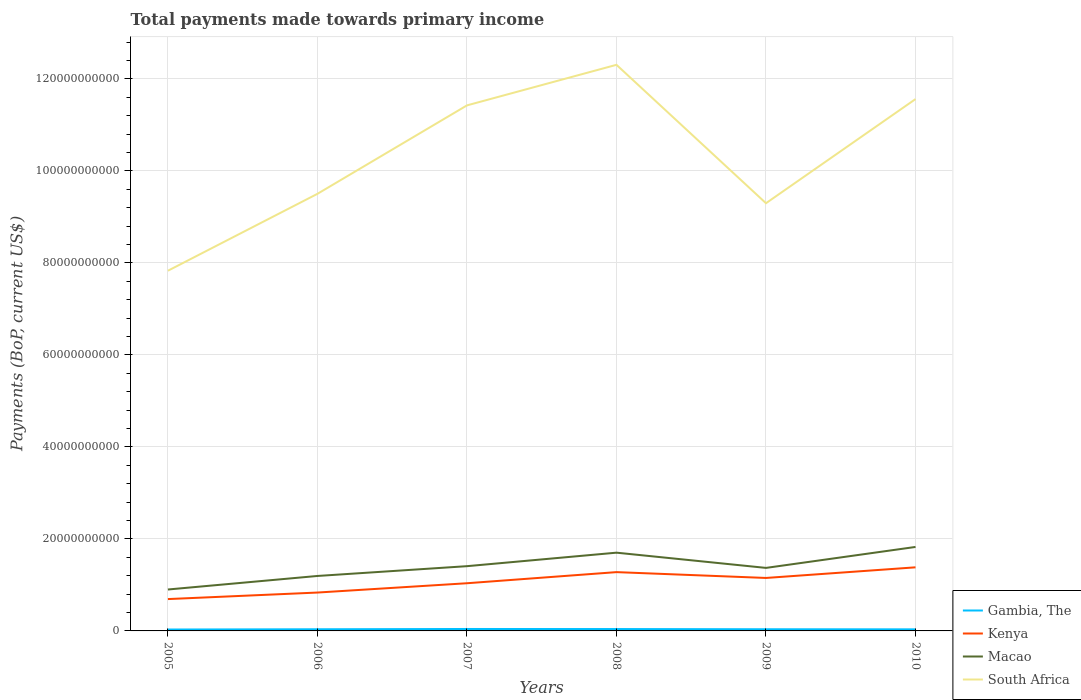How many different coloured lines are there?
Keep it short and to the point. 4. Across all years, what is the maximum total payments made towards primary income in Gambia, The?
Your answer should be compact. 3.05e+08. What is the total total payments made towards primary income in South Africa in the graph?
Make the answer very short. 3.01e+1. What is the difference between the highest and the second highest total payments made towards primary income in Kenya?
Offer a very short reply. 6.90e+09. Is the total payments made towards primary income in Gambia, The strictly greater than the total payments made towards primary income in Kenya over the years?
Make the answer very short. Yes. Are the values on the major ticks of Y-axis written in scientific E-notation?
Ensure brevity in your answer.  No. Does the graph contain grids?
Give a very brief answer. Yes. Where does the legend appear in the graph?
Offer a very short reply. Bottom right. How are the legend labels stacked?
Your answer should be compact. Vertical. What is the title of the graph?
Your answer should be very brief. Total payments made towards primary income. What is the label or title of the Y-axis?
Provide a short and direct response. Payments (BoP, current US$). What is the Payments (BoP, current US$) in Gambia, The in 2005?
Offer a very short reply. 3.05e+08. What is the Payments (BoP, current US$) of Kenya in 2005?
Offer a very short reply. 6.92e+09. What is the Payments (BoP, current US$) of Macao in 2005?
Your answer should be compact. 9.00e+09. What is the Payments (BoP, current US$) in South Africa in 2005?
Your response must be concise. 7.83e+1. What is the Payments (BoP, current US$) of Gambia, The in 2006?
Ensure brevity in your answer.  3.59e+08. What is the Payments (BoP, current US$) in Kenya in 2006?
Your answer should be very brief. 8.34e+09. What is the Payments (BoP, current US$) in Macao in 2006?
Make the answer very short. 1.19e+1. What is the Payments (BoP, current US$) in South Africa in 2006?
Your answer should be compact. 9.50e+1. What is the Payments (BoP, current US$) in Gambia, The in 2007?
Give a very brief answer. 4.20e+08. What is the Payments (BoP, current US$) of Kenya in 2007?
Your response must be concise. 1.04e+1. What is the Payments (BoP, current US$) of Macao in 2007?
Ensure brevity in your answer.  1.41e+1. What is the Payments (BoP, current US$) of South Africa in 2007?
Ensure brevity in your answer.  1.14e+11. What is the Payments (BoP, current US$) in Gambia, The in 2008?
Offer a very short reply. 4.07e+08. What is the Payments (BoP, current US$) in Kenya in 2008?
Make the answer very short. 1.28e+1. What is the Payments (BoP, current US$) in Macao in 2008?
Your answer should be very brief. 1.70e+1. What is the Payments (BoP, current US$) of South Africa in 2008?
Make the answer very short. 1.23e+11. What is the Payments (BoP, current US$) of Gambia, The in 2009?
Make the answer very short. 3.62e+08. What is the Payments (BoP, current US$) in Kenya in 2009?
Your answer should be very brief. 1.15e+1. What is the Payments (BoP, current US$) of Macao in 2009?
Provide a succinct answer. 1.37e+1. What is the Payments (BoP, current US$) in South Africa in 2009?
Keep it short and to the point. 9.30e+1. What is the Payments (BoP, current US$) of Gambia, The in 2010?
Your answer should be compact. 3.41e+08. What is the Payments (BoP, current US$) of Kenya in 2010?
Make the answer very short. 1.38e+1. What is the Payments (BoP, current US$) in Macao in 2010?
Offer a terse response. 1.83e+1. What is the Payments (BoP, current US$) in South Africa in 2010?
Ensure brevity in your answer.  1.16e+11. Across all years, what is the maximum Payments (BoP, current US$) in Gambia, The?
Give a very brief answer. 4.20e+08. Across all years, what is the maximum Payments (BoP, current US$) of Kenya?
Your answer should be very brief. 1.38e+1. Across all years, what is the maximum Payments (BoP, current US$) in Macao?
Provide a short and direct response. 1.83e+1. Across all years, what is the maximum Payments (BoP, current US$) in South Africa?
Your answer should be very brief. 1.23e+11. Across all years, what is the minimum Payments (BoP, current US$) in Gambia, The?
Ensure brevity in your answer.  3.05e+08. Across all years, what is the minimum Payments (BoP, current US$) in Kenya?
Provide a short and direct response. 6.92e+09. Across all years, what is the minimum Payments (BoP, current US$) in Macao?
Offer a very short reply. 9.00e+09. Across all years, what is the minimum Payments (BoP, current US$) of South Africa?
Provide a short and direct response. 7.83e+1. What is the total Payments (BoP, current US$) of Gambia, The in the graph?
Provide a short and direct response. 2.19e+09. What is the total Payments (BoP, current US$) in Kenya in the graph?
Give a very brief answer. 6.37e+1. What is the total Payments (BoP, current US$) in Macao in the graph?
Your answer should be very brief. 8.40e+1. What is the total Payments (BoP, current US$) of South Africa in the graph?
Make the answer very short. 6.19e+11. What is the difference between the Payments (BoP, current US$) in Gambia, The in 2005 and that in 2006?
Your answer should be compact. -5.36e+07. What is the difference between the Payments (BoP, current US$) in Kenya in 2005 and that in 2006?
Your response must be concise. -1.42e+09. What is the difference between the Payments (BoP, current US$) in Macao in 2005 and that in 2006?
Give a very brief answer. -2.94e+09. What is the difference between the Payments (BoP, current US$) of South Africa in 2005 and that in 2006?
Offer a terse response. -1.67e+1. What is the difference between the Payments (BoP, current US$) of Gambia, The in 2005 and that in 2007?
Give a very brief answer. -1.15e+08. What is the difference between the Payments (BoP, current US$) of Kenya in 2005 and that in 2007?
Ensure brevity in your answer.  -3.44e+09. What is the difference between the Payments (BoP, current US$) in Macao in 2005 and that in 2007?
Make the answer very short. -5.07e+09. What is the difference between the Payments (BoP, current US$) of South Africa in 2005 and that in 2007?
Give a very brief answer. -3.59e+1. What is the difference between the Payments (BoP, current US$) of Gambia, The in 2005 and that in 2008?
Give a very brief answer. -1.02e+08. What is the difference between the Payments (BoP, current US$) of Kenya in 2005 and that in 2008?
Offer a terse response. -5.86e+09. What is the difference between the Payments (BoP, current US$) of Macao in 2005 and that in 2008?
Your answer should be very brief. -8.00e+09. What is the difference between the Payments (BoP, current US$) of South Africa in 2005 and that in 2008?
Your answer should be very brief. -4.48e+1. What is the difference between the Payments (BoP, current US$) of Gambia, The in 2005 and that in 2009?
Make the answer very short. -5.73e+07. What is the difference between the Payments (BoP, current US$) of Kenya in 2005 and that in 2009?
Keep it short and to the point. -4.59e+09. What is the difference between the Payments (BoP, current US$) in Macao in 2005 and that in 2009?
Your answer should be very brief. -4.69e+09. What is the difference between the Payments (BoP, current US$) of South Africa in 2005 and that in 2009?
Make the answer very short. -1.47e+1. What is the difference between the Payments (BoP, current US$) in Gambia, The in 2005 and that in 2010?
Give a very brief answer. -3.63e+07. What is the difference between the Payments (BoP, current US$) of Kenya in 2005 and that in 2010?
Keep it short and to the point. -6.90e+09. What is the difference between the Payments (BoP, current US$) in Macao in 2005 and that in 2010?
Your response must be concise. -9.25e+09. What is the difference between the Payments (BoP, current US$) in South Africa in 2005 and that in 2010?
Your answer should be compact. -3.73e+1. What is the difference between the Payments (BoP, current US$) of Gambia, The in 2006 and that in 2007?
Ensure brevity in your answer.  -6.12e+07. What is the difference between the Payments (BoP, current US$) in Kenya in 2006 and that in 2007?
Give a very brief answer. -2.02e+09. What is the difference between the Payments (BoP, current US$) of Macao in 2006 and that in 2007?
Offer a very short reply. -2.13e+09. What is the difference between the Payments (BoP, current US$) of South Africa in 2006 and that in 2007?
Ensure brevity in your answer.  -1.92e+1. What is the difference between the Payments (BoP, current US$) of Gambia, The in 2006 and that in 2008?
Your answer should be very brief. -4.87e+07. What is the difference between the Payments (BoP, current US$) of Kenya in 2006 and that in 2008?
Offer a terse response. -4.44e+09. What is the difference between the Payments (BoP, current US$) of Macao in 2006 and that in 2008?
Offer a terse response. -5.06e+09. What is the difference between the Payments (BoP, current US$) of South Africa in 2006 and that in 2008?
Give a very brief answer. -2.80e+1. What is the difference between the Payments (BoP, current US$) of Gambia, The in 2006 and that in 2009?
Provide a succinct answer. -3.62e+06. What is the difference between the Payments (BoP, current US$) of Kenya in 2006 and that in 2009?
Offer a very short reply. -3.17e+09. What is the difference between the Payments (BoP, current US$) of Macao in 2006 and that in 2009?
Keep it short and to the point. -1.75e+09. What is the difference between the Payments (BoP, current US$) in South Africa in 2006 and that in 2009?
Give a very brief answer. 2.04e+09. What is the difference between the Payments (BoP, current US$) in Gambia, The in 2006 and that in 2010?
Your answer should be very brief. 1.73e+07. What is the difference between the Payments (BoP, current US$) of Kenya in 2006 and that in 2010?
Provide a short and direct response. -5.48e+09. What is the difference between the Payments (BoP, current US$) of Macao in 2006 and that in 2010?
Offer a terse response. -6.31e+09. What is the difference between the Payments (BoP, current US$) in South Africa in 2006 and that in 2010?
Offer a terse response. -2.06e+1. What is the difference between the Payments (BoP, current US$) in Gambia, The in 2007 and that in 2008?
Offer a very short reply. 1.25e+07. What is the difference between the Payments (BoP, current US$) of Kenya in 2007 and that in 2008?
Offer a terse response. -2.42e+09. What is the difference between the Payments (BoP, current US$) in Macao in 2007 and that in 2008?
Offer a very short reply. -2.93e+09. What is the difference between the Payments (BoP, current US$) in South Africa in 2007 and that in 2008?
Your answer should be very brief. -8.82e+09. What is the difference between the Payments (BoP, current US$) of Gambia, The in 2007 and that in 2009?
Make the answer very short. 5.75e+07. What is the difference between the Payments (BoP, current US$) of Kenya in 2007 and that in 2009?
Offer a very short reply. -1.15e+09. What is the difference between the Payments (BoP, current US$) of Macao in 2007 and that in 2009?
Offer a terse response. 3.76e+08. What is the difference between the Payments (BoP, current US$) of South Africa in 2007 and that in 2009?
Offer a very short reply. 2.13e+1. What is the difference between the Payments (BoP, current US$) in Gambia, The in 2007 and that in 2010?
Ensure brevity in your answer.  7.85e+07. What is the difference between the Payments (BoP, current US$) in Kenya in 2007 and that in 2010?
Keep it short and to the point. -3.46e+09. What is the difference between the Payments (BoP, current US$) of Macao in 2007 and that in 2010?
Ensure brevity in your answer.  -4.18e+09. What is the difference between the Payments (BoP, current US$) in South Africa in 2007 and that in 2010?
Provide a short and direct response. -1.37e+09. What is the difference between the Payments (BoP, current US$) of Gambia, The in 2008 and that in 2009?
Offer a terse response. 4.51e+07. What is the difference between the Payments (BoP, current US$) of Kenya in 2008 and that in 2009?
Your answer should be compact. 1.27e+09. What is the difference between the Payments (BoP, current US$) in Macao in 2008 and that in 2009?
Give a very brief answer. 3.31e+09. What is the difference between the Payments (BoP, current US$) in South Africa in 2008 and that in 2009?
Your answer should be very brief. 3.01e+1. What is the difference between the Payments (BoP, current US$) in Gambia, The in 2008 and that in 2010?
Your response must be concise. 6.60e+07. What is the difference between the Payments (BoP, current US$) in Kenya in 2008 and that in 2010?
Offer a very short reply. -1.04e+09. What is the difference between the Payments (BoP, current US$) of Macao in 2008 and that in 2010?
Your response must be concise. -1.25e+09. What is the difference between the Payments (BoP, current US$) of South Africa in 2008 and that in 2010?
Offer a very short reply. 7.45e+09. What is the difference between the Payments (BoP, current US$) of Gambia, The in 2009 and that in 2010?
Ensure brevity in your answer.  2.10e+07. What is the difference between the Payments (BoP, current US$) of Kenya in 2009 and that in 2010?
Your response must be concise. -2.31e+09. What is the difference between the Payments (BoP, current US$) of Macao in 2009 and that in 2010?
Keep it short and to the point. -4.56e+09. What is the difference between the Payments (BoP, current US$) in South Africa in 2009 and that in 2010?
Your answer should be compact. -2.26e+1. What is the difference between the Payments (BoP, current US$) of Gambia, The in 2005 and the Payments (BoP, current US$) of Kenya in 2006?
Offer a very short reply. -8.04e+09. What is the difference between the Payments (BoP, current US$) in Gambia, The in 2005 and the Payments (BoP, current US$) in Macao in 2006?
Ensure brevity in your answer.  -1.16e+1. What is the difference between the Payments (BoP, current US$) in Gambia, The in 2005 and the Payments (BoP, current US$) in South Africa in 2006?
Offer a very short reply. -9.47e+1. What is the difference between the Payments (BoP, current US$) of Kenya in 2005 and the Payments (BoP, current US$) of Macao in 2006?
Offer a terse response. -5.03e+09. What is the difference between the Payments (BoP, current US$) in Kenya in 2005 and the Payments (BoP, current US$) in South Africa in 2006?
Your answer should be compact. -8.81e+1. What is the difference between the Payments (BoP, current US$) of Macao in 2005 and the Payments (BoP, current US$) of South Africa in 2006?
Give a very brief answer. -8.60e+1. What is the difference between the Payments (BoP, current US$) of Gambia, The in 2005 and the Payments (BoP, current US$) of Kenya in 2007?
Give a very brief answer. -1.01e+1. What is the difference between the Payments (BoP, current US$) in Gambia, The in 2005 and the Payments (BoP, current US$) in Macao in 2007?
Your answer should be very brief. -1.38e+1. What is the difference between the Payments (BoP, current US$) of Gambia, The in 2005 and the Payments (BoP, current US$) of South Africa in 2007?
Keep it short and to the point. -1.14e+11. What is the difference between the Payments (BoP, current US$) of Kenya in 2005 and the Payments (BoP, current US$) of Macao in 2007?
Keep it short and to the point. -7.15e+09. What is the difference between the Payments (BoP, current US$) in Kenya in 2005 and the Payments (BoP, current US$) in South Africa in 2007?
Provide a succinct answer. -1.07e+11. What is the difference between the Payments (BoP, current US$) of Macao in 2005 and the Payments (BoP, current US$) of South Africa in 2007?
Your response must be concise. -1.05e+11. What is the difference between the Payments (BoP, current US$) in Gambia, The in 2005 and the Payments (BoP, current US$) in Kenya in 2008?
Your answer should be very brief. -1.25e+1. What is the difference between the Payments (BoP, current US$) of Gambia, The in 2005 and the Payments (BoP, current US$) of Macao in 2008?
Offer a very short reply. -1.67e+1. What is the difference between the Payments (BoP, current US$) of Gambia, The in 2005 and the Payments (BoP, current US$) of South Africa in 2008?
Keep it short and to the point. -1.23e+11. What is the difference between the Payments (BoP, current US$) in Kenya in 2005 and the Payments (BoP, current US$) in Macao in 2008?
Give a very brief answer. -1.01e+1. What is the difference between the Payments (BoP, current US$) of Kenya in 2005 and the Payments (BoP, current US$) of South Africa in 2008?
Your response must be concise. -1.16e+11. What is the difference between the Payments (BoP, current US$) of Macao in 2005 and the Payments (BoP, current US$) of South Africa in 2008?
Offer a terse response. -1.14e+11. What is the difference between the Payments (BoP, current US$) in Gambia, The in 2005 and the Payments (BoP, current US$) in Kenya in 2009?
Give a very brief answer. -1.12e+1. What is the difference between the Payments (BoP, current US$) in Gambia, The in 2005 and the Payments (BoP, current US$) in Macao in 2009?
Ensure brevity in your answer.  -1.34e+1. What is the difference between the Payments (BoP, current US$) of Gambia, The in 2005 and the Payments (BoP, current US$) of South Africa in 2009?
Give a very brief answer. -9.27e+1. What is the difference between the Payments (BoP, current US$) in Kenya in 2005 and the Payments (BoP, current US$) in Macao in 2009?
Keep it short and to the point. -6.78e+09. What is the difference between the Payments (BoP, current US$) of Kenya in 2005 and the Payments (BoP, current US$) of South Africa in 2009?
Your answer should be compact. -8.60e+1. What is the difference between the Payments (BoP, current US$) in Macao in 2005 and the Payments (BoP, current US$) in South Africa in 2009?
Give a very brief answer. -8.40e+1. What is the difference between the Payments (BoP, current US$) in Gambia, The in 2005 and the Payments (BoP, current US$) in Kenya in 2010?
Give a very brief answer. -1.35e+1. What is the difference between the Payments (BoP, current US$) of Gambia, The in 2005 and the Payments (BoP, current US$) of Macao in 2010?
Offer a terse response. -1.79e+1. What is the difference between the Payments (BoP, current US$) in Gambia, The in 2005 and the Payments (BoP, current US$) in South Africa in 2010?
Provide a short and direct response. -1.15e+11. What is the difference between the Payments (BoP, current US$) of Kenya in 2005 and the Payments (BoP, current US$) of Macao in 2010?
Make the answer very short. -1.13e+1. What is the difference between the Payments (BoP, current US$) in Kenya in 2005 and the Payments (BoP, current US$) in South Africa in 2010?
Provide a short and direct response. -1.09e+11. What is the difference between the Payments (BoP, current US$) in Macao in 2005 and the Payments (BoP, current US$) in South Africa in 2010?
Make the answer very short. -1.07e+11. What is the difference between the Payments (BoP, current US$) of Gambia, The in 2006 and the Payments (BoP, current US$) of Kenya in 2007?
Offer a very short reply. -1.00e+1. What is the difference between the Payments (BoP, current US$) in Gambia, The in 2006 and the Payments (BoP, current US$) in Macao in 2007?
Your answer should be compact. -1.37e+1. What is the difference between the Payments (BoP, current US$) in Gambia, The in 2006 and the Payments (BoP, current US$) in South Africa in 2007?
Offer a terse response. -1.14e+11. What is the difference between the Payments (BoP, current US$) in Kenya in 2006 and the Payments (BoP, current US$) in Macao in 2007?
Ensure brevity in your answer.  -5.73e+09. What is the difference between the Payments (BoP, current US$) in Kenya in 2006 and the Payments (BoP, current US$) in South Africa in 2007?
Your response must be concise. -1.06e+11. What is the difference between the Payments (BoP, current US$) of Macao in 2006 and the Payments (BoP, current US$) of South Africa in 2007?
Offer a very short reply. -1.02e+11. What is the difference between the Payments (BoP, current US$) of Gambia, The in 2006 and the Payments (BoP, current US$) of Kenya in 2008?
Give a very brief answer. -1.24e+1. What is the difference between the Payments (BoP, current US$) of Gambia, The in 2006 and the Payments (BoP, current US$) of Macao in 2008?
Keep it short and to the point. -1.66e+1. What is the difference between the Payments (BoP, current US$) in Gambia, The in 2006 and the Payments (BoP, current US$) in South Africa in 2008?
Give a very brief answer. -1.23e+11. What is the difference between the Payments (BoP, current US$) in Kenya in 2006 and the Payments (BoP, current US$) in Macao in 2008?
Your answer should be very brief. -8.67e+09. What is the difference between the Payments (BoP, current US$) in Kenya in 2006 and the Payments (BoP, current US$) in South Africa in 2008?
Make the answer very short. -1.15e+11. What is the difference between the Payments (BoP, current US$) of Macao in 2006 and the Payments (BoP, current US$) of South Africa in 2008?
Make the answer very short. -1.11e+11. What is the difference between the Payments (BoP, current US$) of Gambia, The in 2006 and the Payments (BoP, current US$) of Kenya in 2009?
Offer a very short reply. -1.12e+1. What is the difference between the Payments (BoP, current US$) in Gambia, The in 2006 and the Payments (BoP, current US$) in Macao in 2009?
Offer a terse response. -1.33e+1. What is the difference between the Payments (BoP, current US$) in Gambia, The in 2006 and the Payments (BoP, current US$) in South Africa in 2009?
Ensure brevity in your answer.  -9.26e+1. What is the difference between the Payments (BoP, current US$) of Kenya in 2006 and the Payments (BoP, current US$) of Macao in 2009?
Ensure brevity in your answer.  -5.36e+09. What is the difference between the Payments (BoP, current US$) of Kenya in 2006 and the Payments (BoP, current US$) of South Africa in 2009?
Your response must be concise. -8.46e+1. What is the difference between the Payments (BoP, current US$) in Macao in 2006 and the Payments (BoP, current US$) in South Africa in 2009?
Ensure brevity in your answer.  -8.10e+1. What is the difference between the Payments (BoP, current US$) of Gambia, The in 2006 and the Payments (BoP, current US$) of Kenya in 2010?
Ensure brevity in your answer.  -1.35e+1. What is the difference between the Payments (BoP, current US$) of Gambia, The in 2006 and the Payments (BoP, current US$) of Macao in 2010?
Keep it short and to the point. -1.79e+1. What is the difference between the Payments (BoP, current US$) in Gambia, The in 2006 and the Payments (BoP, current US$) in South Africa in 2010?
Offer a very short reply. -1.15e+11. What is the difference between the Payments (BoP, current US$) in Kenya in 2006 and the Payments (BoP, current US$) in Macao in 2010?
Ensure brevity in your answer.  -9.91e+09. What is the difference between the Payments (BoP, current US$) of Kenya in 2006 and the Payments (BoP, current US$) of South Africa in 2010?
Offer a very short reply. -1.07e+11. What is the difference between the Payments (BoP, current US$) in Macao in 2006 and the Payments (BoP, current US$) in South Africa in 2010?
Offer a terse response. -1.04e+11. What is the difference between the Payments (BoP, current US$) in Gambia, The in 2007 and the Payments (BoP, current US$) in Kenya in 2008?
Ensure brevity in your answer.  -1.24e+1. What is the difference between the Payments (BoP, current US$) of Gambia, The in 2007 and the Payments (BoP, current US$) of Macao in 2008?
Offer a very short reply. -1.66e+1. What is the difference between the Payments (BoP, current US$) of Gambia, The in 2007 and the Payments (BoP, current US$) of South Africa in 2008?
Provide a short and direct response. -1.23e+11. What is the difference between the Payments (BoP, current US$) of Kenya in 2007 and the Payments (BoP, current US$) of Macao in 2008?
Offer a terse response. -6.64e+09. What is the difference between the Payments (BoP, current US$) in Kenya in 2007 and the Payments (BoP, current US$) in South Africa in 2008?
Your answer should be very brief. -1.13e+11. What is the difference between the Payments (BoP, current US$) in Macao in 2007 and the Payments (BoP, current US$) in South Africa in 2008?
Your answer should be very brief. -1.09e+11. What is the difference between the Payments (BoP, current US$) in Gambia, The in 2007 and the Payments (BoP, current US$) in Kenya in 2009?
Ensure brevity in your answer.  -1.11e+1. What is the difference between the Payments (BoP, current US$) of Gambia, The in 2007 and the Payments (BoP, current US$) of Macao in 2009?
Offer a terse response. -1.33e+1. What is the difference between the Payments (BoP, current US$) of Gambia, The in 2007 and the Payments (BoP, current US$) of South Africa in 2009?
Offer a very short reply. -9.25e+1. What is the difference between the Payments (BoP, current US$) of Kenya in 2007 and the Payments (BoP, current US$) of Macao in 2009?
Make the answer very short. -3.33e+09. What is the difference between the Payments (BoP, current US$) of Kenya in 2007 and the Payments (BoP, current US$) of South Africa in 2009?
Make the answer very short. -8.26e+1. What is the difference between the Payments (BoP, current US$) in Macao in 2007 and the Payments (BoP, current US$) in South Africa in 2009?
Your answer should be compact. -7.89e+1. What is the difference between the Payments (BoP, current US$) of Gambia, The in 2007 and the Payments (BoP, current US$) of Kenya in 2010?
Offer a terse response. -1.34e+1. What is the difference between the Payments (BoP, current US$) in Gambia, The in 2007 and the Payments (BoP, current US$) in Macao in 2010?
Keep it short and to the point. -1.78e+1. What is the difference between the Payments (BoP, current US$) of Gambia, The in 2007 and the Payments (BoP, current US$) of South Africa in 2010?
Offer a very short reply. -1.15e+11. What is the difference between the Payments (BoP, current US$) in Kenya in 2007 and the Payments (BoP, current US$) in Macao in 2010?
Ensure brevity in your answer.  -7.89e+09. What is the difference between the Payments (BoP, current US$) of Kenya in 2007 and the Payments (BoP, current US$) of South Africa in 2010?
Make the answer very short. -1.05e+11. What is the difference between the Payments (BoP, current US$) of Macao in 2007 and the Payments (BoP, current US$) of South Africa in 2010?
Offer a very short reply. -1.02e+11. What is the difference between the Payments (BoP, current US$) in Gambia, The in 2008 and the Payments (BoP, current US$) in Kenya in 2009?
Your answer should be very brief. -1.11e+1. What is the difference between the Payments (BoP, current US$) of Gambia, The in 2008 and the Payments (BoP, current US$) of Macao in 2009?
Your answer should be compact. -1.33e+1. What is the difference between the Payments (BoP, current US$) in Gambia, The in 2008 and the Payments (BoP, current US$) in South Africa in 2009?
Make the answer very short. -9.26e+1. What is the difference between the Payments (BoP, current US$) in Kenya in 2008 and the Payments (BoP, current US$) in Macao in 2009?
Offer a very short reply. -9.18e+08. What is the difference between the Payments (BoP, current US$) of Kenya in 2008 and the Payments (BoP, current US$) of South Africa in 2009?
Your answer should be compact. -8.02e+1. What is the difference between the Payments (BoP, current US$) of Macao in 2008 and the Payments (BoP, current US$) of South Africa in 2009?
Your answer should be compact. -7.60e+1. What is the difference between the Payments (BoP, current US$) of Gambia, The in 2008 and the Payments (BoP, current US$) of Kenya in 2010?
Provide a short and direct response. -1.34e+1. What is the difference between the Payments (BoP, current US$) of Gambia, The in 2008 and the Payments (BoP, current US$) of Macao in 2010?
Ensure brevity in your answer.  -1.78e+1. What is the difference between the Payments (BoP, current US$) in Gambia, The in 2008 and the Payments (BoP, current US$) in South Africa in 2010?
Give a very brief answer. -1.15e+11. What is the difference between the Payments (BoP, current US$) in Kenya in 2008 and the Payments (BoP, current US$) in Macao in 2010?
Ensure brevity in your answer.  -5.47e+09. What is the difference between the Payments (BoP, current US$) of Kenya in 2008 and the Payments (BoP, current US$) of South Africa in 2010?
Provide a succinct answer. -1.03e+11. What is the difference between the Payments (BoP, current US$) in Macao in 2008 and the Payments (BoP, current US$) in South Africa in 2010?
Make the answer very short. -9.86e+1. What is the difference between the Payments (BoP, current US$) of Gambia, The in 2009 and the Payments (BoP, current US$) of Kenya in 2010?
Provide a succinct answer. -1.35e+1. What is the difference between the Payments (BoP, current US$) in Gambia, The in 2009 and the Payments (BoP, current US$) in Macao in 2010?
Give a very brief answer. -1.79e+1. What is the difference between the Payments (BoP, current US$) of Gambia, The in 2009 and the Payments (BoP, current US$) of South Africa in 2010?
Ensure brevity in your answer.  -1.15e+11. What is the difference between the Payments (BoP, current US$) of Kenya in 2009 and the Payments (BoP, current US$) of Macao in 2010?
Ensure brevity in your answer.  -6.74e+09. What is the difference between the Payments (BoP, current US$) of Kenya in 2009 and the Payments (BoP, current US$) of South Africa in 2010?
Offer a very short reply. -1.04e+11. What is the difference between the Payments (BoP, current US$) of Macao in 2009 and the Payments (BoP, current US$) of South Africa in 2010?
Provide a short and direct response. -1.02e+11. What is the average Payments (BoP, current US$) of Gambia, The per year?
Provide a short and direct response. 3.66e+08. What is the average Payments (BoP, current US$) of Kenya per year?
Provide a short and direct response. 1.06e+1. What is the average Payments (BoP, current US$) of Macao per year?
Offer a terse response. 1.40e+1. What is the average Payments (BoP, current US$) of South Africa per year?
Ensure brevity in your answer.  1.03e+11. In the year 2005, what is the difference between the Payments (BoP, current US$) in Gambia, The and Payments (BoP, current US$) in Kenya?
Offer a very short reply. -6.62e+09. In the year 2005, what is the difference between the Payments (BoP, current US$) of Gambia, The and Payments (BoP, current US$) of Macao?
Make the answer very short. -8.70e+09. In the year 2005, what is the difference between the Payments (BoP, current US$) in Gambia, The and Payments (BoP, current US$) in South Africa?
Provide a short and direct response. -7.80e+1. In the year 2005, what is the difference between the Payments (BoP, current US$) of Kenya and Payments (BoP, current US$) of Macao?
Make the answer very short. -2.08e+09. In the year 2005, what is the difference between the Payments (BoP, current US$) in Kenya and Payments (BoP, current US$) in South Africa?
Offer a terse response. -7.14e+1. In the year 2005, what is the difference between the Payments (BoP, current US$) of Macao and Payments (BoP, current US$) of South Africa?
Offer a very short reply. -6.93e+1. In the year 2006, what is the difference between the Payments (BoP, current US$) in Gambia, The and Payments (BoP, current US$) in Kenya?
Give a very brief answer. -7.98e+09. In the year 2006, what is the difference between the Payments (BoP, current US$) in Gambia, The and Payments (BoP, current US$) in Macao?
Provide a succinct answer. -1.16e+1. In the year 2006, what is the difference between the Payments (BoP, current US$) of Gambia, The and Payments (BoP, current US$) of South Africa?
Your answer should be compact. -9.46e+1. In the year 2006, what is the difference between the Payments (BoP, current US$) of Kenya and Payments (BoP, current US$) of Macao?
Make the answer very short. -3.61e+09. In the year 2006, what is the difference between the Payments (BoP, current US$) of Kenya and Payments (BoP, current US$) of South Africa?
Your response must be concise. -8.67e+1. In the year 2006, what is the difference between the Payments (BoP, current US$) in Macao and Payments (BoP, current US$) in South Africa?
Provide a succinct answer. -8.31e+1. In the year 2007, what is the difference between the Payments (BoP, current US$) in Gambia, The and Payments (BoP, current US$) in Kenya?
Offer a terse response. -9.94e+09. In the year 2007, what is the difference between the Payments (BoP, current US$) in Gambia, The and Payments (BoP, current US$) in Macao?
Your answer should be compact. -1.37e+1. In the year 2007, what is the difference between the Payments (BoP, current US$) of Gambia, The and Payments (BoP, current US$) of South Africa?
Provide a short and direct response. -1.14e+11. In the year 2007, what is the difference between the Payments (BoP, current US$) of Kenya and Payments (BoP, current US$) of Macao?
Make the answer very short. -3.71e+09. In the year 2007, what is the difference between the Payments (BoP, current US$) of Kenya and Payments (BoP, current US$) of South Africa?
Provide a succinct answer. -1.04e+11. In the year 2007, what is the difference between the Payments (BoP, current US$) of Macao and Payments (BoP, current US$) of South Africa?
Ensure brevity in your answer.  -1.00e+11. In the year 2008, what is the difference between the Payments (BoP, current US$) in Gambia, The and Payments (BoP, current US$) in Kenya?
Provide a short and direct response. -1.24e+1. In the year 2008, what is the difference between the Payments (BoP, current US$) in Gambia, The and Payments (BoP, current US$) in Macao?
Offer a terse response. -1.66e+1. In the year 2008, what is the difference between the Payments (BoP, current US$) of Gambia, The and Payments (BoP, current US$) of South Africa?
Keep it short and to the point. -1.23e+11. In the year 2008, what is the difference between the Payments (BoP, current US$) of Kenya and Payments (BoP, current US$) of Macao?
Your answer should be very brief. -4.23e+09. In the year 2008, what is the difference between the Payments (BoP, current US$) in Kenya and Payments (BoP, current US$) in South Africa?
Offer a terse response. -1.10e+11. In the year 2008, what is the difference between the Payments (BoP, current US$) of Macao and Payments (BoP, current US$) of South Africa?
Provide a short and direct response. -1.06e+11. In the year 2009, what is the difference between the Payments (BoP, current US$) of Gambia, The and Payments (BoP, current US$) of Kenya?
Keep it short and to the point. -1.12e+1. In the year 2009, what is the difference between the Payments (BoP, current US$) of Gambia, The and Payments (BoP, current US$) of Macao?
Give a very brief answer. -1.33e+1. In the year 2009, what is the difference between the Payments (BoP, current US$) of Gambia, The and Payments (BoP, current US$) of South Africa?
Make the answer very short. -9.26e+1. In the year 2009, what is the difference between the Payments (BoP, current US$) of Kenya and Payments (BoP, current US$) of Macao?
Offer a very short reply. -2.18e+09. In the year 2009, what is the difference between the Payments (BoP, current US$) of Kenya and Payments (BoP, current US$) of South Africa?
Offer a terse response. -8.15e+1. In the year 2009, what is the difference between the Payments (BoP, current US$) in Macao and Payments (BoP, current US$) in South Africa?
Give a very brief answer. -7.93e+1. In the year 2010, what is the difference between the Payments (BoP, current US$) in Gambia, The and Payments (BoP, current US$) in Kenya?
Offer a very short reply. -1.35e+1. In the year 2010, what is the difference between the Payments (BoP, current US$) in Gambia, The and Payments (BoP, current US$) in Macao?
Offer a terse response. -1.79e+1. In the year 2010, what is the difference between the Payments (BoP, current US$) of Gambia, The and Payments (BoP, current US$) of South Africa?
Your answer should be very brief. -1.15e+11. In the year 2010, what is the difference between the Payments (BoP, current US$) of Kenya and Payments (BoP, current US$) of Macao?
Your answer should be very brief. -4.43e+09. In the year 2010, what is the difference between the Payments (BoP, current US$) of Kenya and Payments (BoP, current US$) of South Africa?
Provide a succinct answer. -1.02e+11. In the year 2010, what is the difference between the Payments (BoP, current US$) in Macao and Payments (BoP, current US$) in South Africa?
Your response must be concise. -9.73e+1. What is the ratio of the Payments (BoP, current US$) in Gambia, The in 2005 to that in 2006?
Provide a succinct answer. 0.85. What is the ratio of the Payments (BoP, current US$) of Kenya in 2005 to that in 2006?
Give a very brief answer. 0.83. What is the ratio of the Payments (BoP, current US$) of Macao in 2005 to that in 2006?
Your answer should be compact. 0.75. What is the ratio of the Payments (BoP, current US$) in South Africa in 2005 to that in 2006?
Ensure brevity in your answer.  0.82. What is the ratio of the Payments (BoP, current US$) in Gambia, The in 2005 to that in 2007?
Your answer should be very brief. 0.73. What is the ratio of the Payments (BoP, current US$) of Kenya in 2005 to that in 2007?
Your response must be concise. 0.67. What is the ratio of the Payments (BoP, current US$) of Macao in 2005 to that in 2007?
Offer a terse response. 0.64. What is the ratio of the Payments (BoP, current US$) in South Africa in 2005 to that in 2007?
Offer a very short reply. 0.69. What is the ratio of the Payments (BoP, current US$) of Gambia, The in 2005 to that in 2008?
Offer a terse response. 0.75. What is the ratio of the Payments (BoP, current US$) in Kenya in 2005 to that in 2008?
Provide a succinct answer. 0.54. What is the ratio of the Payments (BoP, current US$) of Macao in 2005 to that in 2008?
Make the answer very short. 0.53. What is the ratio of the Payments (BoP, current US$) of South Africa in 2005 to that in 2008?
Offer a very short reply. 0.64. What is the ratio of the Payments (BoP, current US$) of Gambia, The in 2005 to that in 2009?
Make the answer very short. 0.84. What is the ratio of the Payments (BoP, current US$) in Kenya in 2005 to that in 2009?
Keep it short and to the point. 0.6. What is the ratio of the Payments (BoP, current US$) in Macao in 2005 to that in 2009?
Your response must be concise. 0.66. What is the ratio of the Payments (BoP, current US$) of South Africa in 2005 to that in 2009?
Keep it short and to the point. 0.84. What is the ratio of the Payments (BoP, current US$) of Gambia, The in 2005 to that in 2010?
Your answer should be compact. 0.89. What is the ratio of the Payments (BoP, current US$) of Kenya in 2005 to that in 2010?
Your response must be concise. 0.5. What is the ratio of the Payments (BoP, current US$) in Macao in 2005 to that in 2010?
Offer a terse response. 0.49. What is the ratio of the Payments (BoP, current US$) in South Africa in 2005 to that in 2010?
Give a very brief answer. 0.68. What is the ratio of the Payments (BoP, current US$) in Gambia, The in 2006 to that in 2007?
Provide a short and direct response. 0.85. What is the ratio of the Payments (BoP, current US$) in Kenya in 2006 to that in 2007?
Keep it short and to the point. 0.8. What is the ratio of the Payments (BoP, current US$) in Macao in 2006 to that in 2007?
Offer a very short reply. 0.85. What is the ratio of the Payments (BoP, current US$) in South Africa in 2006 to that in 2007?
Make the answer very short. 0.83. What is the ratio of the Payments (BoP, current US$) of Gambia, The in 2006 to that in 2008?
Offer a terse response. 0.88. What is the ratio of the Payments (BoP, current US$) of Kenya in 2006 to that in 2008?
Your response must be concise. 0.65. What is the ratio of the Payments (BoP, current US$) in Macao in 2006 to that in 2008?
Ensure brevity in your answer.  0.7. What is the ratio of the Payments (BoP, current US$) of South Africa in 2006 to that in 2008?
Offer a very short reply. 0.77. What is the ratio of the Payments (BoP, current US$) of Kenya in 2006 to that in 2009?
Your response must be concise. 0.72. What is the ratio of the Payments (BoP, current US$) in Macao in 2006 to that in 2009?
Provide a succinct answer. 0.87. What is the ratio of the Payments (BoP, current US$) in South Africa in 2006 to that in 2009?
Offer a very short reply. 1.02. What is the ratio of the Payments (BoP, current US$) of Gambia, The in 2006 to that in 2010?
Make the answer very short. 1.05. What is the ratio of the Payments (BoP, current US$) in Kenya in 2006 to that in 2010?
Your answer should be compact. 0.6. What is the ratio of the Payments (BoP, current US$) of Macao in 2006 to that in 2010?
Your answer should be very brief. 0.65. What is the ratio of the Payments (BoP, current US$) in South Africa in 2006 to that in 2010?
Give a very brief answer. 0.82. What is the ratio of the Payments (BoP, current US$) of Gambia, The in 2007 to that in 2008?
Offer a very short reply. 1.03. What is the ratio of the Payments (BoP, current US$) of Kenya in 2007 to that in 2008?
Your response must be concise. 0.81. What is the ratio of the Payments (BoP, current US$) in Macao in 2007 to that in 2008?
Keep it short and to the point. 0.83. What is the ratio of the Payments (BoP, current US$) of South Africa in 2007 to that in 2008?
Your answer should be very brief. 0.93. What is the ratio of the Payments (BoP, current US$) in Gambia, The in 2007 to that in 2009?
Provide a short and direct response. 1.16. What is the ratio of the Payments (BoP, current US$) in Kenya in 2007 to that in 2009?
Your answer should be very brief. 0.9. What is the ratio of the Payments (BoP, current US$) of Macao in 2007 to that in 2009?
Your answer should be compact. 1.03. What is the ratio of the Payments (BoP, current US$) of South Africa in 2007 to that in 2009?
Your answer should be compact. 1.23. What is the ratio of the Payments (BoP, current US$) of Gambia, The in 2007 to that in 2010?
Your answer should be compact. 1.23. What is the ratio of the Payments (BoP, current US$) in Kenya in 2007 to that in 2010?
Keep it short and to the point. 0.75. What is the ratio of the Payments (BoP, current US$) in Macao in 2007 to that in 2010?
Your answer should be very brief. 0.77. What is the ratio of the Payments (BoP, current US$) in South Africa in 2007 to that in 2010?
Your answer should be compact. 0.99. What is the ratio of the Payments (BoP, current US$) of Gambia, The in 2008 to that in 2009?
Ensure brevity in your answer.  1.12. What is the ratio of the Payments (BoP, current US$) of Kenya in 2008 to that in 2009?
Provide a short and direct response. 1.11. What is the ratio of the Payments (BoP, current US$) in Macao in 2008 to that in 2009?
Ensure brevity in your answer.  1.24. What is the ratio of the Payments (BoP, current US$) in South Africa in 2008 to that in 2009?
Your answer should be very brief. 1.32. What is the ratio of the Payments (BoP, current US$) of Gambia, The in 2008 to that in 2010?
Make the answer very short. 1.19. What is the ratio of the Payments (BoP, current US$) of Kenya in 2008 to that in 2010?
Offer a very short reply. 0.92. What is the ratio of the Payments (BoP, current US$) of Macao in 2008 to that in 2010?
Ensure brevity in your answer.  0.93. What is the ratio of the Payments (BoP, current US$) in South Africa in 2008 to that in 2010?
Your answer should be compact. 1.06. What is the ratio of the Payments (BoP, current US$) of Gambia, The in 2009 to that in 2010?
Give a very brief answer. 1.06. What is the ratio of the Payments (BoP, current US$) in Kenya in 2009 to that in 2010?
Provide a succinct answer. 0.83. What is the ratio of the Payments (BoP, current US$) of Macao in 2009 to that in 2010?
Keep it short and to the point. 0.75. What is the ratio of the Payments (BoP, current US$) in South Africa in 2009 to that in 2010?
Provide a short and direct response. 0.8. What is the difference between the highest and the second highest Payments (BoP, current US$) of Gambia, The?
Your answer should be very brief. 1.25e+07. What is the difference between the highest and the second highest Payments (BoP, current US$) of Kenya?
Your answer should be compact. 1.04e+09. What is the difference between the highest and the second highest Payments (BoP, current US$) in Macao?
Provide a succinct answer. 1.25e+09. What is the difference between the highest and the second highest Payments (BoP, current US$) of South Africa?
Offer a terse response. 7.45e+09. What is the difference between the highest and the lowest Payments (BoP, current US$) of Gambia, The?
Give a very brief answer. 1.15e+08. What is the difference between the highest and the lowest Payments (BoP, current US$) of Kenya?
Make the answer very short. 6.90e+09. What is the difference between the highest and the lowest Payments (BoP, current US$) in Macao?
Provide a succinct answer. 9.25e+09. What is the difference between the highest and the lowest Payments (BoP, current US$) in South Africa?
Your answer should be very brief. 4.48e+1. 